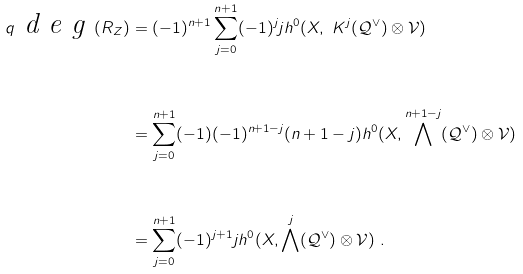Convert formula to latex. <formula><loc_0><loc_0><loc_500><loc_500>q \emph { d e g } ( R _ { Z } ) & = ( - 1 ) ^ { n + 1 } \sum _ { j = 0 } ^ { n + 1 } ( - 1 ) ^ { j } j h ^ { 0 } ( X , \ K ^ { j } ( \mathcal { Q } ^ { \vee } ) \otimes \mathcal { V } ) \\ \ \\ & = \sum _ { j = 0 } ^ { n + 1 } ( - 1 ) ( - 1 ) ^ { n + 1 - j } ( n + 1 - j ) h ^ { 0 } ( X , \bigwedge ^ { n + 1 - j } ( \mathcal { Q } ^ { \vee } ) \otimes \mathcal { V } ) \\ \ \\ & = \sum _ { j = 0 } ^ { n + 1 } ( - 1 ) ^ { j + 1 } j h ^ { 0 } ( X , \bigwedge ^ { j } ( \mathcal { Q } ^ { \vee } ) \otimes \mathcal { V } ) \ .</formula> 